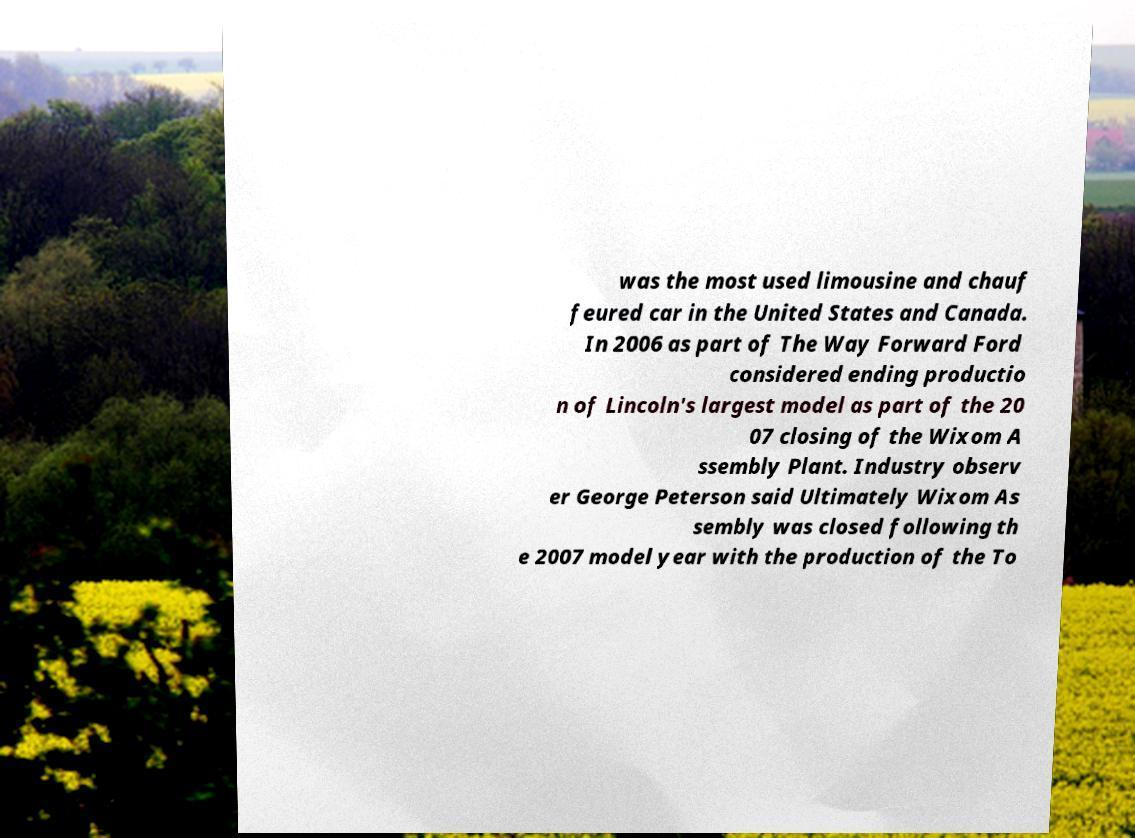Could you extract and type out the text from this image? was the most used limousine and chauf feured car in the United States and Canada. In 2006 as part of The Way Forward Ford considered ending productio n of Lincoln's largest model as part of the 20 07 closing of the Wixom A ssembly Plant. Industry observ er George Peterson said Ultimately Wixom As sembly was closed following th e 2007 model year with the production of the To 